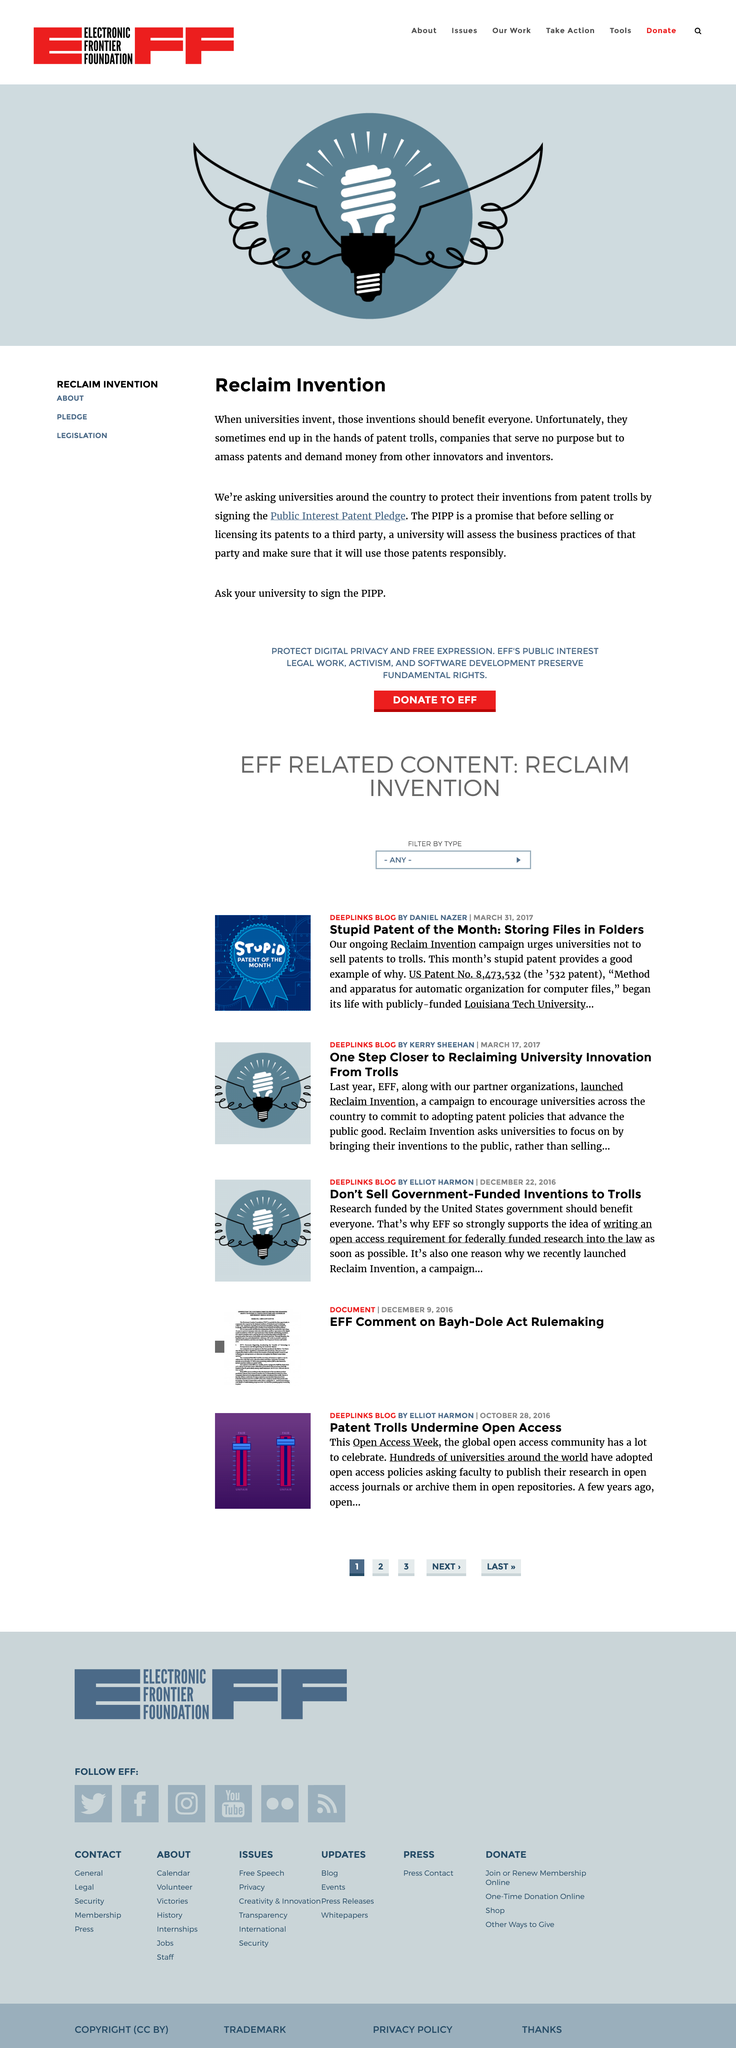Identify some key points in this picture. University inventions, all too often, end up in the hands of patent trolls. The PIPP is intended to promote the dissemination and use of the inventions of universities for the benefit of society as a whole. The acronym PIPP stands for Public Interest Patent Pledge, a commitment by organizations to use their patents in the public interest, such as for the development of affordable healthcare and the promotion of environmental sustainability. 